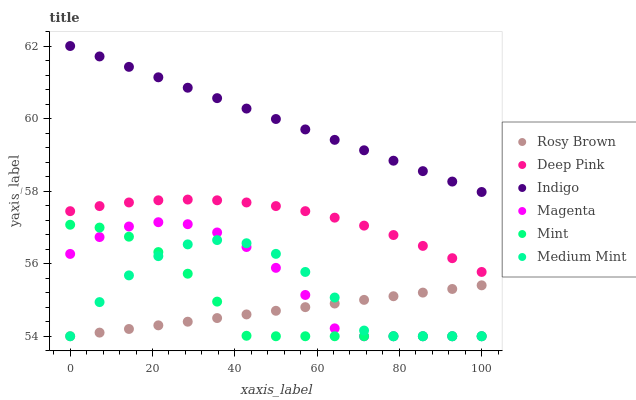Does Rosy Brown have the minimum area under the curve?
Answer yes or no. Yes. Does Indigo have the maximum area under the curve?
Answer yes or no. Yes. Does Deep Pink have the minimum area under the curve?
Answer yes or no. No. Does Deep Pink have the maximum area under the curve?
Answer yes or no. No. Is Indigo the smoothest?
Answer yes or no. Yes. Is Medium Mint the roughest?
Answer yes or no. Yes. Is Deep Pink the smoothest?
Answer yes or no. No. Is Deep Pink the roughest?
Answer yes or no. No. Does Medium Mint have the lowest value?
Answer yes or no. Yes. Does Deep Pink have the lowest value?
Answer yes or no. No. Does Indigo have the highest value?
Answer yes or no. Yes. Does Deep Pink have the highest value?
Answer yes or no. No. Is Rosy Brown less than Deep Pink?
Answer yes or no. Yes. Is Indigo greater than Mint?
Answer yes or no. Yes. Does Magenta intersect Rosy Brown?
Answer yes or no. Yes. Is Magenta less than Rosy Brown?
Answer yes or no. No. Is Magenta greater than Rosy Brown?
Answer yes or no. No. Does Rosy Brown intersect Deep Pink?
Answer yes or no. No. 